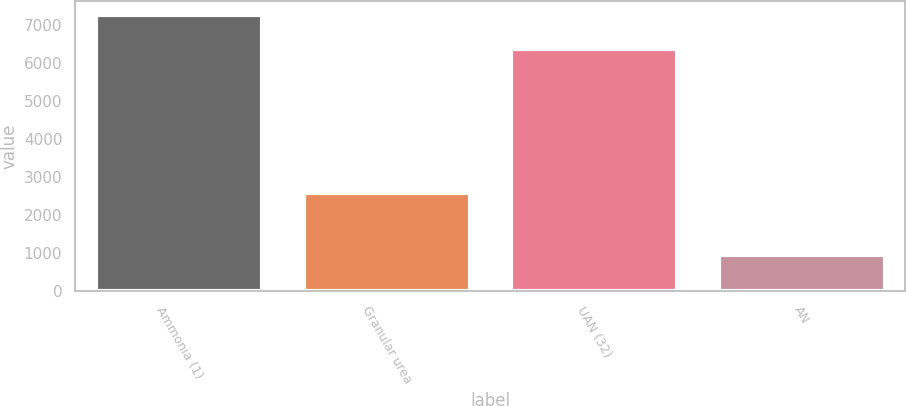<chart> <loc_0><loc_0><loc_500><loc_500><bar_chart><fcel>Ammonia (1)<fcel>Granular urea<fcel>UAN (32)<fcel>AN<nl><fcel>7244<fcel>2588<fcel>6349<fcel>952<nl></chart> 